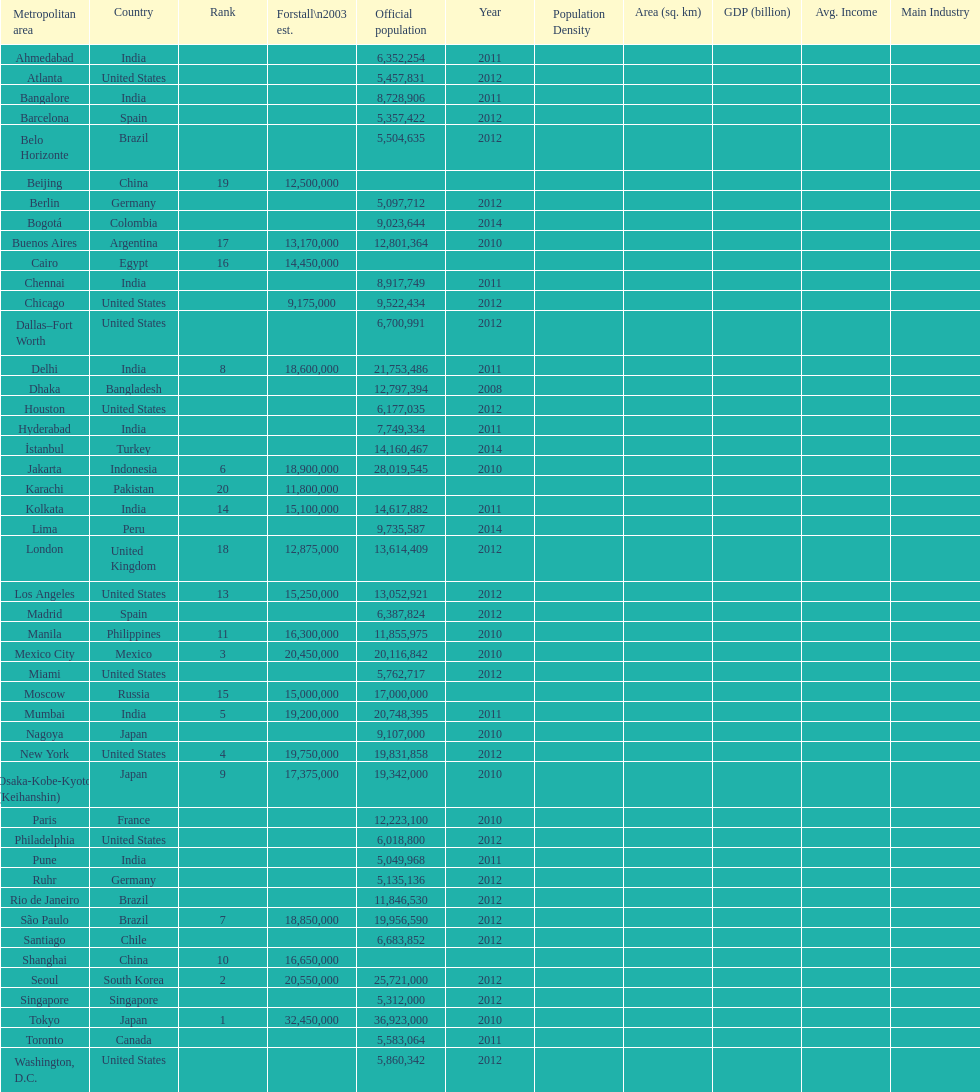What city was ranked first in 2003? Tokyo. 